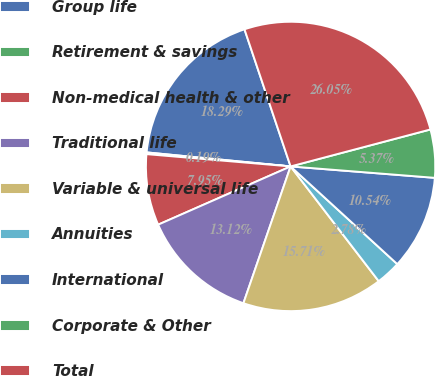Convert chart to OTSL. <chart><loc_0><loc_0><loc_500><loc_500><pie_chart><fcel>Group life<fcel>Retirement & savings<fcel>Non-medical health & other<fcel>Traditional life<fcel>Variable & universal life<fcel>Annuities<fcel>International<fcel>Corporate & Other<fcel>Total<nl><fcel>18.29%<fcel>0.19%<fcel>7.95%<fcel>13.12%<fcel>15.71%<fcel>2.78%<fcel>10.54%<fcel>5.37%<fcel>26.05%<nl></chart> 